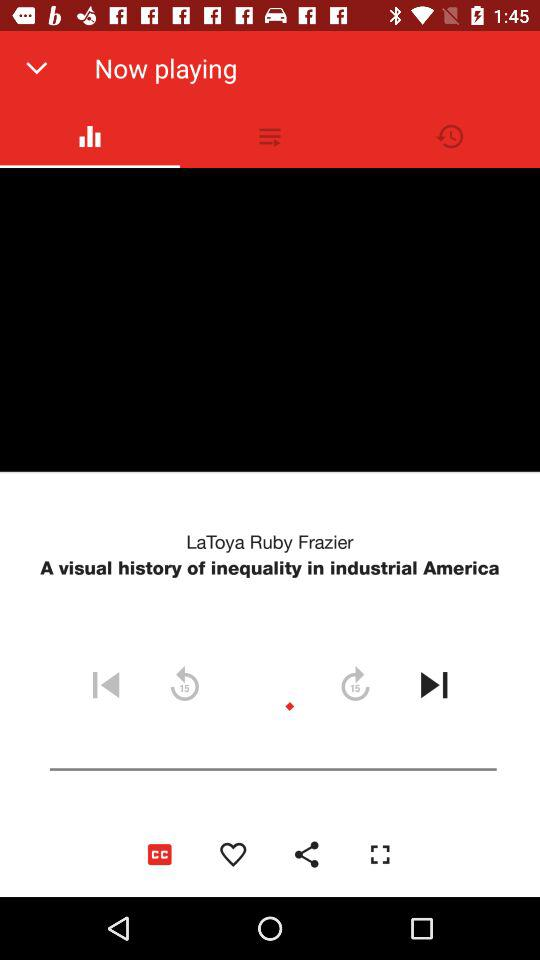How long is "A visual history of inequality in industrial America"?
When the provided information is insufficient, respond with <no answer>. <no answer> 